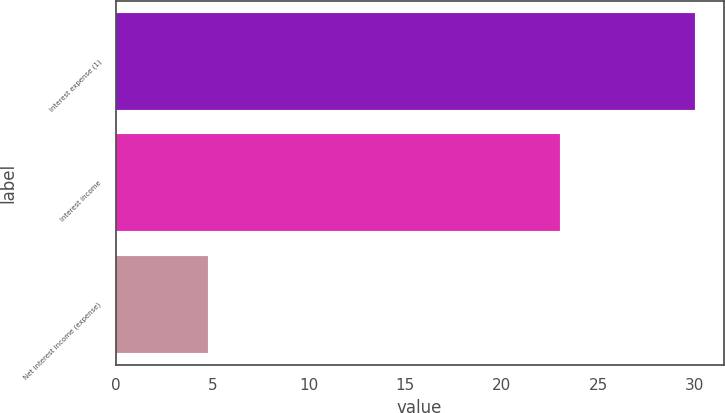<chart> <loc_0><loc_0><loc_500><loc_500><bar_chart><fcel>Interest expense (1)<fcel>Interest income<fcel>Net interest income (expense)<nl><fcel>30<fcel>23<fcel>4.8<nl></chart> 